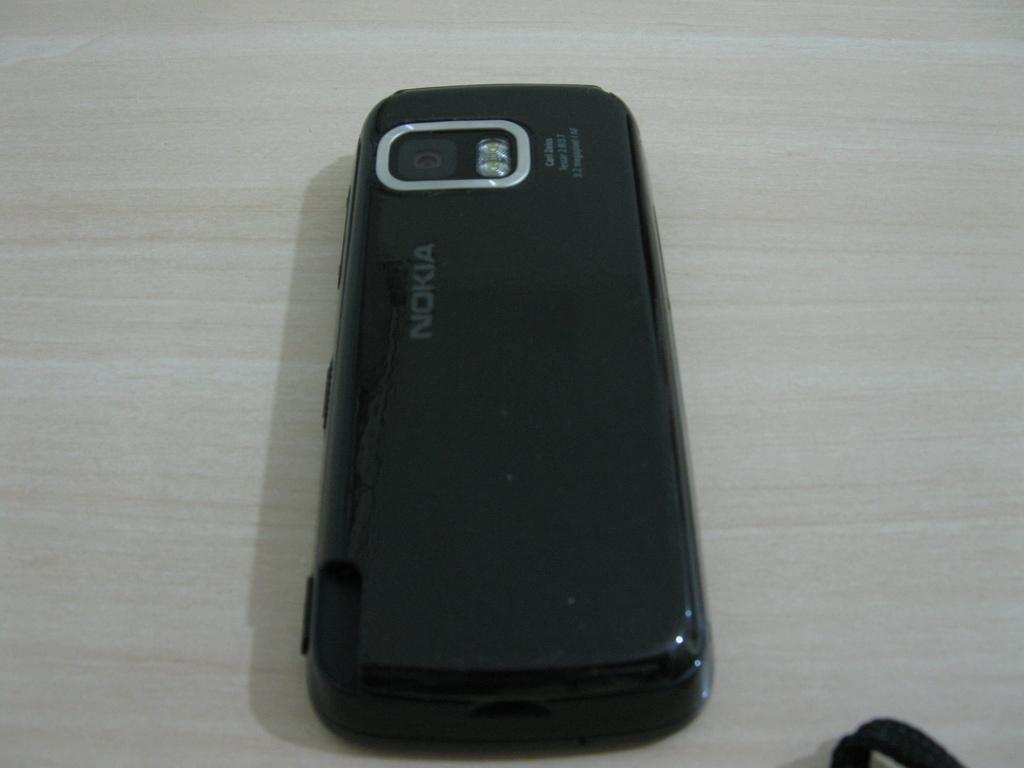<image>
Offer a succinct explanation of the picture presented. A NOKIA phone face down on a table 